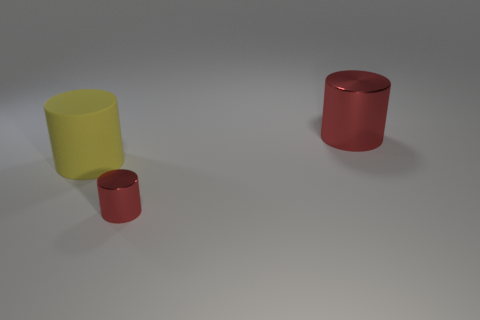Add 3 rubber objects. How many objects exist? 6 Add 1 rubber things. How many rubber things exist? 2 Subtract 0 red balls. How many objects are left? 3 Subtract all cyan blocks. Subtract all large cylinders. How many objects are left? 1 Add 3 large yellow cylinders. How many large yellow cylinders are left? 4 